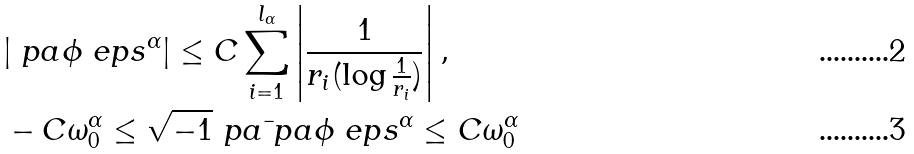<formula> <loc_0><loc_0><loc_500><loc_500>& | \ p a \phi _ { \ } e p s ^ { \alpha } | \leq C \sum _ { i = 1 } ^ { l _ { \alpha } } \left | \frac { 1 } { r _ { i } ( \log \frac { 1 } { r _ { i } } ) } \right | , \\ & - C \omega ^ { \alpha } _ { 0 } \leq \sqrt { - 1 } \ p a \bar { \ } p a \phi _ { \ } e p s ^ { \alpha } \leq C \omega _ { 0 } ^ { \alpha }</formula> 